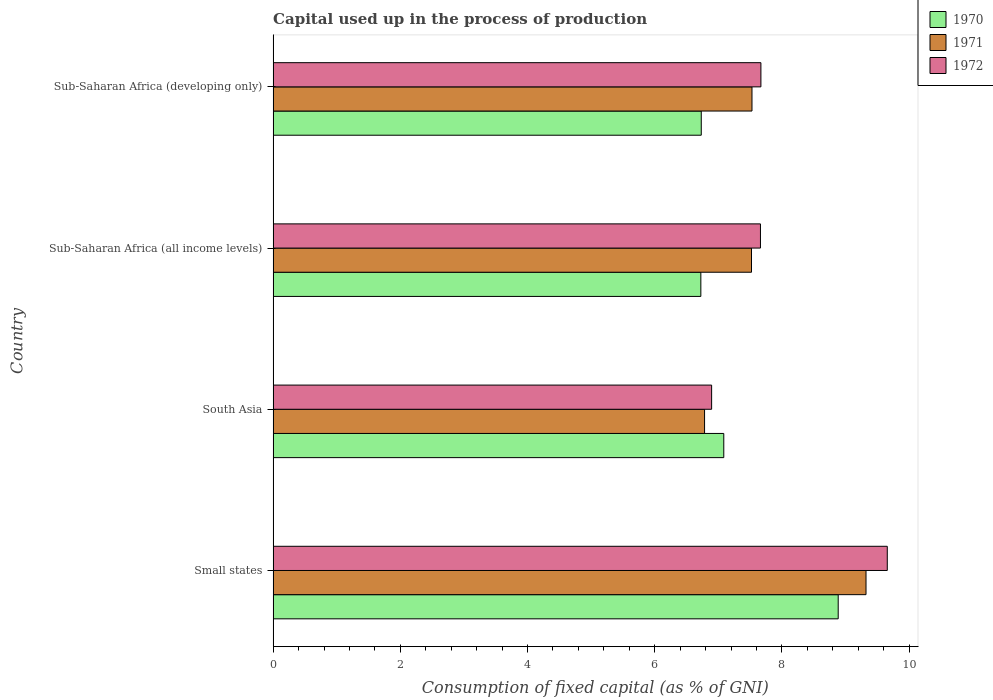How many different coloured bars are there?
Your answer should be compact. 3. Are the number of bars per tick equal to the number of legend labels?
Provide a short and direct response. Yes. How many bars are there on the 3rd tick from the bottom?
Your answer should be compact. 3. What is the label of the 2nd group of bars from the top?
Keep it short and to the point. Sub-Saharan Africa (all income levels). In how many cases, is the number of bars for a given country not equal to the number of legend labels?
Offer a terse response. 0. What is the capital used up in the process of production in 1972 in Small states?
Provide a succinct answer. 9.66. Across all countries, what is the maximum capital used up in the process of production in 1971?
Offer a terse response. 9.32. Across all countries, what is the minimum capital used up in the process of production in 1971?
Your response must be concise. 6.78. In which country was the capital used up in the process of production in 1971 maximum?
Your answer should be compact. Small states. What is the total capital used up in the process of production in 1971 in the graph?
Provide a succinct answer. 31.16. What is the difference between the capital used up in the process of production in 1972 in South Asia and that in Sub-Saharan Africa (developing only)?
Make the answer very short. -0.77. What is the difference between the capital used up in the process of production in 1972 in Sub-Saharan Africa (all income levels) and the capital used up in the process of production in 1970 in Small states?
Provide a succinct answer. -1.22. What is the average capital used up in the process of production in 1972 per country?
Your response must be concise. 7.97. What is the difference between the capital used up in the process of production in 1972 and capital used up in the process of production in 1971 in Sub-Saharan Africa (all income levels)?
Your response must be concise. 0.14. What is the ratio of the capital used up in the process of production in 1970 in Small states to that in Sub-Saharan Africa (developing only)?
Your answer should be very brief. 1.32. Is the capital used up in the process of production in 1971 in Sub-Saharan Africa (all income levels) less than that in Sub-Saharan Africa (developing only)?
Ensure brevity in your answer.  Yes. What is the difference between the highest and the second highest capital used up in the process of production in 1972?
Your answer should be compact. 1.99. What is the difference between the highest and the lowest capital used up in the process of production in 1971?
Your response must be concise. 2.54. Is the sum of the capital used up in the process of production in 1971 in Small states and South Asia greater than the maximum capital used up in the process of production in 1970 across all countries?
Your response must be concise. Yes. What does the 2nd bar from the top in Sub-Saharan Africa (all income levels) represents?
Your response must be concise. 1971. How many bars are there?
Your response must be concise. 12. Are all the bars in the graph horizontal?
Your answer should be compact. Yes. Does the graph contain grids?
Your answer should be very brief. No. Where does the legend appear in the graph?
Your answer should be compact. Top right. How many legend labels are there?
Give a very brief answer. 3. What is the title of the graph?
Provide a succinct answer. Capital used up in the process of production. What is the label or title of the X-axis?
Offer a terse response. Consumption of fixed capital (as % of GNI). What is the label or title of the Y-axis?
Make the answer very short. Country. What is the Consumption of fixed capital (as % of GNI) in 1970 in Small states?
Give a very brief answer. 8.88. What is the Consumption of fixed capital (as % of GNI) of 1971 in Small states?
Keep it short and to the point. 9.32. What is the Consumption of fixed capital (as % of GNI) of 1972 in Small states?
Ensure brevity in your answer.  9.66. What is the Consumption of fixed capital (as % of GNI) of 1970 in South Asia?
Your answer should be very brief. 7.09. What is the Consumption of fixed capital (as % of GNI) of 1971 in South Asia?
Provide a short and direct response. 6.78. What is the Consumption of fixed capital (as % of GNI) in 1972 in South Asia?
Offer a very short reply. 6.89. What is the Consumption of fixed capital (as % of GNI) of 1970 in Sub-Saharan Africa (all income levels)?
Offer a terse response. 6.72. What is the Consumption of fixed capital (as % of GNI) of 1971 in Sub-Saharan Africa (all income levels)?
Keep it short and to the point. 7.52. What is the Consumption of fixed capital (as % of GNI) of 1972 in Sub-Saharan Africa (all income levels)?
Provide a short and direct response. 7.66. What is the Consumption of fixed capital (as % of GNI) in 1970 in Sub-Saharan Africa (developing only)?
Keep it short and to the point. 6.73. What is the Consumption of fixed capital (as % of GNI) of 1971 in Sub-Saharan Africa (developing only)?
Offer a very short reply. 7.53. What is the Consumption of fixed capital (as % of GNI) of 1972 in Sub-Saharan Africa (developing only)?
Your answer should be very brief. 7.67. Across all countries, what is the maximum Consumption of fixed capital (as % of GNI) of 1970?
Your response must be concise. 8.88. Across all countries, what is the maximum Consumption of fixed capital (as % of GNI) of 1971?
Keep it short and to the point. 9.32. Across all countries, what is the maximum Consumption of fixed capital (as % of GNI) in 1972?
Your response must be concise. 9.66. Across all countries, what is the minimum Consumption of fixed capital (as % of GNI) of 1970?
Your response must be concise. 6.72. Across all countries, what is the minimum Consumption of fixed capital (as % of GNI) of 1971?
Ensure brevity in your answer.  6.78. Across all countries, what is the minimum Consumption of fixed capital (as % of GNI) of 1972?
Provide a succinct answer. 6.89. What is the total Consumption of fixed capital (as % of GNI) of 1970 in the graph?
Give a very brief answer. 29.43. What is the total Consumption of fixed capital (as % of GNI) in 1971 in the graph?
Your response must be concise. 31.16. What is the total Consumption of fixed capital (as % of GNI) of 1972 in the graph?
Your answer should be very brief. 31.88. What is the difference between the Consumption of fixed capital (as % of GNI) in 1970 in Small states and that in South Asia?
Your answer should be compact. 1.8. What is the difference between the Consumption of fixed capital (as % of GNI) in 1971 in Small states and that in South Asia?
Your answer should be very brief. 2.54. What is the difference between the Consumption of fixed capital (as % of GNI) of 1972 in Small states and that in South Asia?
Give a very brief answer. 2.76. What is the difference between the Consumption of fixed capital (as % of GNI) in 1970 in Small states and that in Sub-Saharan Africa (all income levels)?
Your response must be concise. 2.16. What is the difference between the Consumption of fixed capital (as % of GNI) of 1971 in Small states and that in Sub-Saharan Africa (all income levels)?
Provide a succinct answer. 1.8. What is the difference between the Consumption of fixed capital (as % of GNI) of 1972 in Small states and that in Sub-Saharan Africa (all income levels)?
Your response must be concise. 1.99. What is the difference between the Consumption of fixed capital (as % of GNI) of 1970 in Small states and that in Sub-Saharan Africa (developing only)?
Your answer should be compact. 2.15. What is the difference between the Consumption of fixed capital (as % of GNI) of 1971 in Small states and that in Sub-Saharan Africa (developing only)?
Offer a very short reply. 1.79. What is the difference between the Consumption of fixed capital (as % of GNI) in 1972 in Small states and that in Sub-Saharan Africa (developing only)?
Provide a succinct answer. 1.99. What is the difference between the Consumption of fixed capital (as % of GNI) in 1970 in South Asia and that in Sub-Saharan Africa (all income levels)?
Offer a terse response. 0.36. What is the difference between the Consumption of fixed capital (as % of GNI) of 1971 in South Asia and that in Sub-Saharan Africa (all income levels)?
Your answer should be very brief. -0.74. What is the difference between the Consumption of fixed capital (as % of GNI) of 1972 in South Asia and that in Sub-Saharan Africa (all income levels)?
Keep it short and to the point. -0.77. What is the difference between the Consumption of fixed capital (as % of GNI) of 1970 in South Asia and that in Sub-Saharan Africa (developing only)?
Provide a succinct answer. 0.35. What is the difference between the Consumption of fixed capital (as % of GNI) in 1971 in South Asia and that in Sub-Saharan Africa (developing only)?
Your response must be concise. -0.75. What is the difference between the Consumption of fixed capital (as % of GNI) of 1972 in South Asia and that in Sub-Saharan Africa (developing only)?
Your response must be concise. -0.77. What is the difference between the Consumption of fixed capital (as % of GNI) of 1970 in Sub-Saharan Africa (all income levels) and that in Sub-Saharan Africa (developing only)?
Give a very brief answer. -0.01. What is the difference between the Consumption of fixed capital (as % of GNI) of 1971 in Sub-Saharan Africa (all income levels) and that in Sub-Saharan Africa (developing only)?
Give a very brief answer. -0.01. What is the difference between the Consumption of fixed capital (as % of GNI) in 1972 in Sub-Saharan Africa (all income levels) and that in Sub-Saharan Africa (developing only)?
Provide a short and direct response. -0.01. What is the difference between the Consumption of fixed capital (as % of GNI) of 1970 in Small states and the Consumption of fixed capital (as % of GNI) of 1971 in South Asia?
Provide a succinct answer. 2.1. What is the difference between the Consumption of fixed capital (as % of GNI) in 1970 in Small states and the Consumption of fixed capital (as % of GNI) in 1972 in South Asia?
Provide a succinct answer. 1.99. What is the difference between the Consumption of fixed capital (as % of GNI) in 1971 in Small states and the Consumption of fixed capital (as % of GNI) in 1972 in South Asia?
Your answer should be very brief. 2.43. What is the difference between the Consumption of fixed capital (as % of GNI) in 1970 in Small states and the Consumption of fixed capital (as % of GNI) in 1971 in Sub-Saharan Africa (all income levels)?
Provide a short and direct response. 1.36. What is the difference between the Consumption of fixed capital (as % of GNI) in 1970 in Small states and the Consumption of fixed capital (as % of GNI) in 1972 in Sub-Saharan Africa (all income levels)?
Provide a succinct answer. 1.22. What is the difference between the Consumption of fixed capital (as % of GNI) in 1971 in Small states and the Consumption of fixed capital (as % of GNI) in 1972 in Sub-Saharan Africa (all income levels)?
Offer a terse response. 1.66. What is the difference between the Consumption of fixed capital (as % of GNI) of 1970 in Small states and the Consumption of fixed capital (as % of GNI) of 1971 in Sub-Saharan Africa (developing only)?
Make the answer very short. 1.36. What is the difference between the Consumption of fixed capital (as % of GNI) of 1970 in Small states and the Consumption of fixed capital (as % of GNI) of 1972 in Sub-Saharan Africa (developing only)?
Offer a terse response. 1.22. What is the difference between the Consumption of fixed capital (as % of GNI) in 1971 in Small states and the Consumption of fixed capital (as % of GNI) in 1972 in Sub-Saharan Africa (developing only)?
Offer a terse response. 1.65. What is the difference between the Consumption of fixed capital (as % of GNI) in 1970 in South Asia and the Consumption of fixed capital (as % of GNI) in 1971 in Sub-Saharan Africa (all income levels)?
Make the answer very short. -0.44. What is the difference between the Consumption of fixed capital (as % of GNI) in 1970 in South Asia and the Consumption of fixed capital (as % of GNI) in 1972 in Sub-Saharan Africa (all income levels)?
Your answer should be very brief. -0.58. What is the difference between the Consumption of fixed capital (as % of GNI) in 1971 in South Asia and the Consumption of fixed capital (as % of GNI) in 1972 in Sub-Saharan Africa (all income levels)?
Offer a very short reply. -0.88. What is the difference between the Consumption of fixed capital (as % of GNI) of 1970 in South Asia and the Consumption of fixed capital (as % of GNI) of 1971 in Sub-Saharan Africa (developing only)?
Ensure brevity in your answer.  -0.44. What is the difference between the Consumption of fixed capital (as % of GNI) in 1970 in South Asia and the Consumption of fixed capital (as % of GNI) in 1972 in Sub-Saharan Africa (developing only)?
Your answer should be compact. -0.58. What is the difference between the Consumption of fixed capital (as % of GNI) in 1971 in South Asia and the Consumption of fixed capital (as % of GNI) in 1972 in Sub-Saharan Africa (developing only)?
Give a very brief answer. -0.89. What is the difference between the Consumption of fixed capital (as % of GNI) in 1970 in Sub-Saharan Africa (all income levels) and the Consumption of fixed capital (as % of GNI) in 1971 in Sub-Saharan Africa (developing only)?
Your answer should be very brief. -0.8. What is the difference between the Consumption of fixed capital (as % of GNI) of 1970 in Sub-Saharan Africa (all income levels) and the Consumption of fixed capital (as % of GNI) of 1972 in Sub-Saharan Africa (developing only)?
Your answer should be compact. -0.94. What is the difference between the Consumption of fixed capital (as % of GNI) of 1971 in Sub-Saharan Africa (all income levels) and the Consumption of fixed capital (as % of GNI) of 1972 in Sub-Saharan Africa (developing only)?
Offer a very short reply. -0.15. What is the average Consumption of fixed capital (as % of GNI) of 1970 per country?
Provide a succinct answer. 7.36. What is the average Consumption of fixed capital (as % of GNI) of 1971 per country?
Offer a terse response. 7.79. What is the average Consumption of fixed capital (as % of GNI) of 1972 per country?
Your answer should be very brief. 7.97. What is the difference between the Consumption of fixed capital (as % of GNI) in 1970 and Consumption of fixed capital (as % of GNI) in 1971 in Small states?
Give a very brief answer. -0.44. What is the difference between the Consumption of fixed capital (as % of GNI) of 1970 and Consumption of fixed capital (as % of GNI) of 1972 in Small states?
Give a very brief answer. -0.77. What is the difference between the Consumption of fixed capital (as % of GNI) in 1971 and Consumption of fixed capital (as % of GNI) in 1972 in Small states?
Ensure brevity in your answer.  -0.33. What is the difference between the Consumption of fixed capital (as % of GNI) in 1970 and Consumption of fixed capital (as % of GNI) in 1971 in South Asia?
Keep it short and to the point. 0.3. What is the difference between the Consumption of fixed capital (as % of GNI) in 1970 and Consumption of fixed capital (as % of GNI) in 1972 in South Asia?
Offer a terse response. 0.19. What is the difference between the Consumption of fixed capital (as % of GNI) in 1971 and Consumption of fixed capital (as % of GNI) in 1972 in South Asia?
Offer a terse response. -0.11. What is the difference between the Consumption of fixed capital (as % of GNI) of 1970 and Consumption of fixed capital (as % of GNI) of 1971 in Sub-Saharan Africa (all income levels)?
Offer a very short reply. -0.8. What is the difference between the Consumption of fixed capital (as % of GNI) of 1970 and Consumption of fixed capital (as % of GNI) of 1972 in Sub-Saharan Africa (all income levels)?
Your answer should be compact. -0.94. What is the difference between the Consumption of fixed capital (as % of GNI) of 1971 and Consumption of fixed capital (as % of GNI) of 1972 in Sub-Saharan Africa (all income levels)?
Your answer should be compact. -0.14. What is the difference between the Consumption of fixed capital (as % of GNI) of 1970 and Consumption of fixed capital (as % of GNI) of 1971 in Sub-Saharan Africa (developing only)?
Provide a succinct answer. -0.8. What is the difference between the Consumption of fixed capital (as % of GNI) of 1970 and Consumption of fixed capital (as % of GNI) of 1972 in Sub-Saharan Africa (developing only)?
Give a very brief answer. -0.94. What is the difference between the Consumption of fixed capital (as % of GNI) of 1971 and Consumption of fixed capital (as % of GNI) of 1972 in Sub-Saharan Africa (developing only)?
Provide a succinct answer. -0.14. What is the ratio of the Consumption of fixed capital (as % of GNI) of 1970 in Small states to that in South Asia?
Make the answer very short. 1.25. What is the ratio of the Consumption of fixed capital (as % of GNI) in 1971 in Small states to that in South Asia?
Ensure brevity in your answer.  1.37. What is the ratio of the Consumption of fixed capital (as % of GNI) of 1972 in Small states to that in South Asia?
Provide a succinct answer. 1.4. What is the ratio of the Consumption of fixed capital (as % of GNI) of 1970 in Small states to that in Sub-Saharan Africa (all income levels)?
Make the answer very short. 1.32. What is the ratio of the Consumption of fixed capital (as % of GNI) of 1971 in Small states to that in Sub-Saharan Africa (all income levels)?
Keep it short and to the point. 1.24. What is the ratio of the Consumption of fixed capital (as % of GNI) in 1972 in Small states to that in Sub-Saharan Africa (all income levels)?
Ensure brevity in your answer.  1.26. What is the ratio of the Consumption of fixed capital (as % of GNI) of 1970 in Small states to that in Sub-Saharan Africa (developing only)?
Your answer should be compact. 1.32. What is the ratio of the Consumption of fixed capital (as % of GNI) of 1971 in Small states to that in Sub-Saharan Africa (developing only)?
Your answer should be very brief. 1.24. What is the ratio of the Consumption of fixed capital (as % of GNI) of 1972 in Small states to that in Sub-Saharan Africa (developing only)?
Offer a very short reply. 1.26. What is the ratio of the Consumption of fixed capital (as % of GNI) of 1970 in South Asia to that in Sub-Saharan Africa (all income levels)?
Give a very brief answer. 1.05. What is the ratio of the Consumption of fixed capital (as % of GNI) of 1971 in South Asia to that in Sub-Saharan Africa (all income levels)?
Provide a succinct answer. 0.9. What is the ratio of the Consumption of fixed capital (as % of GNI) in 1972 in South Asia to that in Sub-Saharan Africa (all income levels)?
Ensure brevity in your answer.  0.9. What is the ratio of the Consumption of fixed capital (as % of GNI) in 1970 in South Asia to that in Sub-Saharan Africa (developing only)?
Ensure brevity in your answer.  1.05. What is the ratio of the Consumption of fixed capital (as % of GNI) in 1971 in South Asia to that in Sub-Saharan Africa (developing only)?
Give a very brief answer. 0.9. What is the ratio of the Consumption of fixed capital (as % of GNI) in 1972 in South Asia to that in Sub-Saharan Africa (developing only)?
Offer a terse response. 0.9. What is the ratio of the Consumption of fixed capital (as % of GNI) in 1971 in Sub-Saharan Africa (all income levels) to that in Sub-Saharan Africa (developing only)?
Your response must be concise. 1. What is the difference between the highest and the second highest Consumption of fixed capital (as % of GNI) in 1970?
Make the answer very short. 1.8. What is the difference between the highest and the second highest Consumption of fixed capital (as % of GNI) of 1971?
Ensure brevity in your answer.  1.79. What is the difference between the highest and the second highest Consumption of fixed capital (as % of GNI) of 1972?
Your answer should be very brief. 1.99. What is the difference between the highest and the lowest Consumption of fixed capital (as % of GNI) in 1970?
Your answer should be compact. 2.16. What is the difference between the highest and the lowest Consumption of fixed capital (as % of GNI) of 1971?
Your answer should be compact. 2.54. What is the difference between the highest and the lowest Consumption of fixed capital (as % of GNI) in 1972?
Your response must be concise. 2.76. 